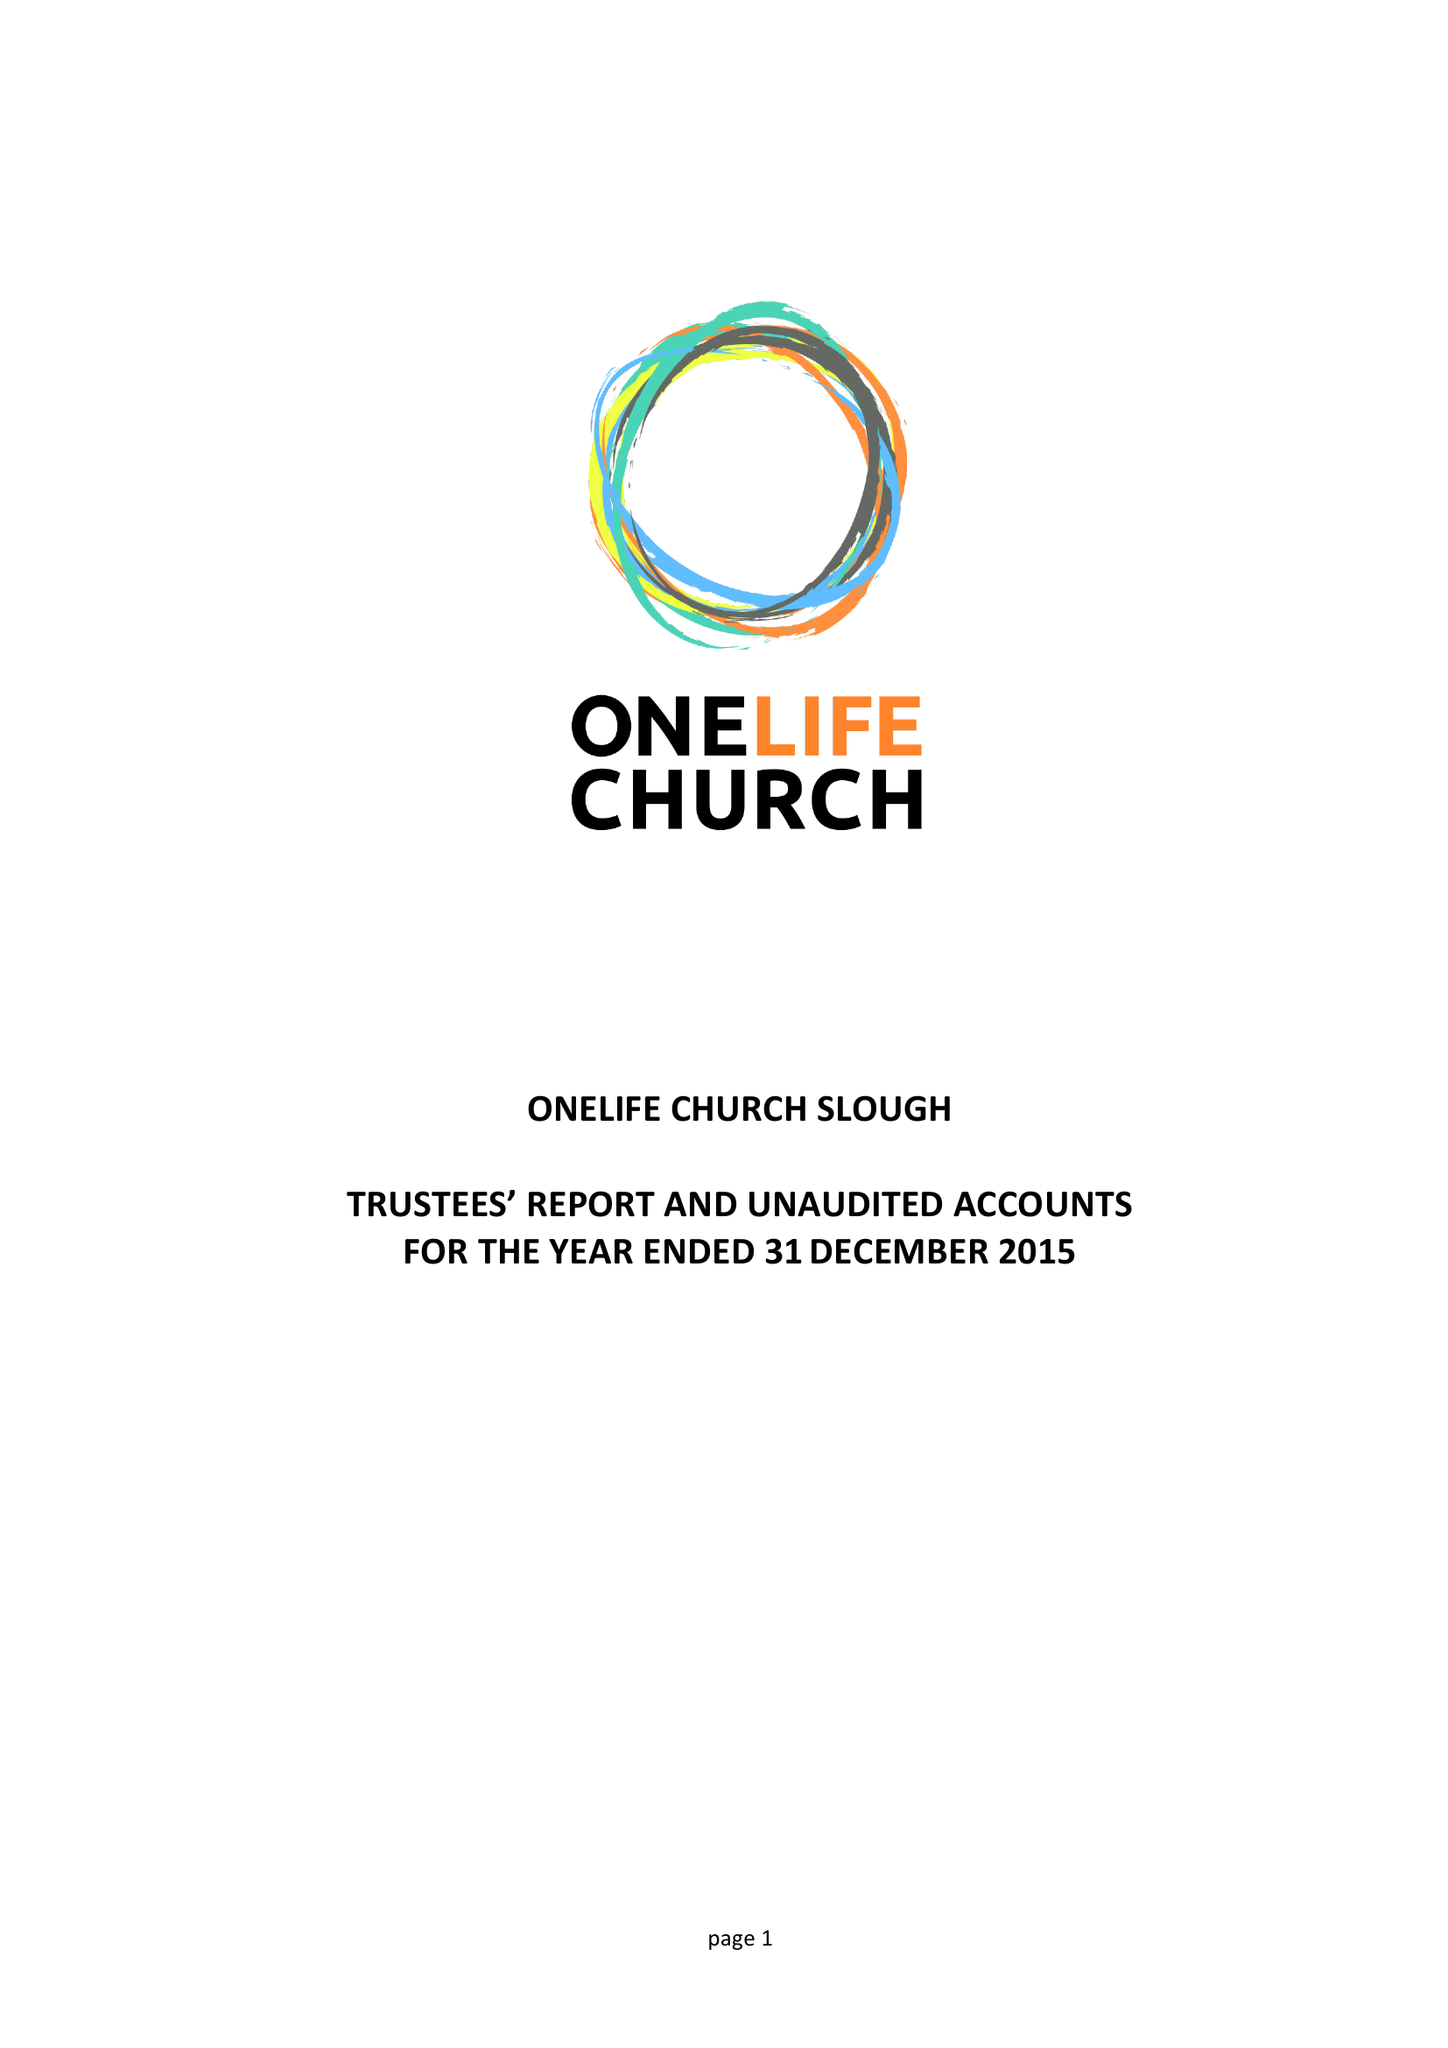What is the value for the address__postcode?
Answer the question using a single word or phrase. SL2 1TY 